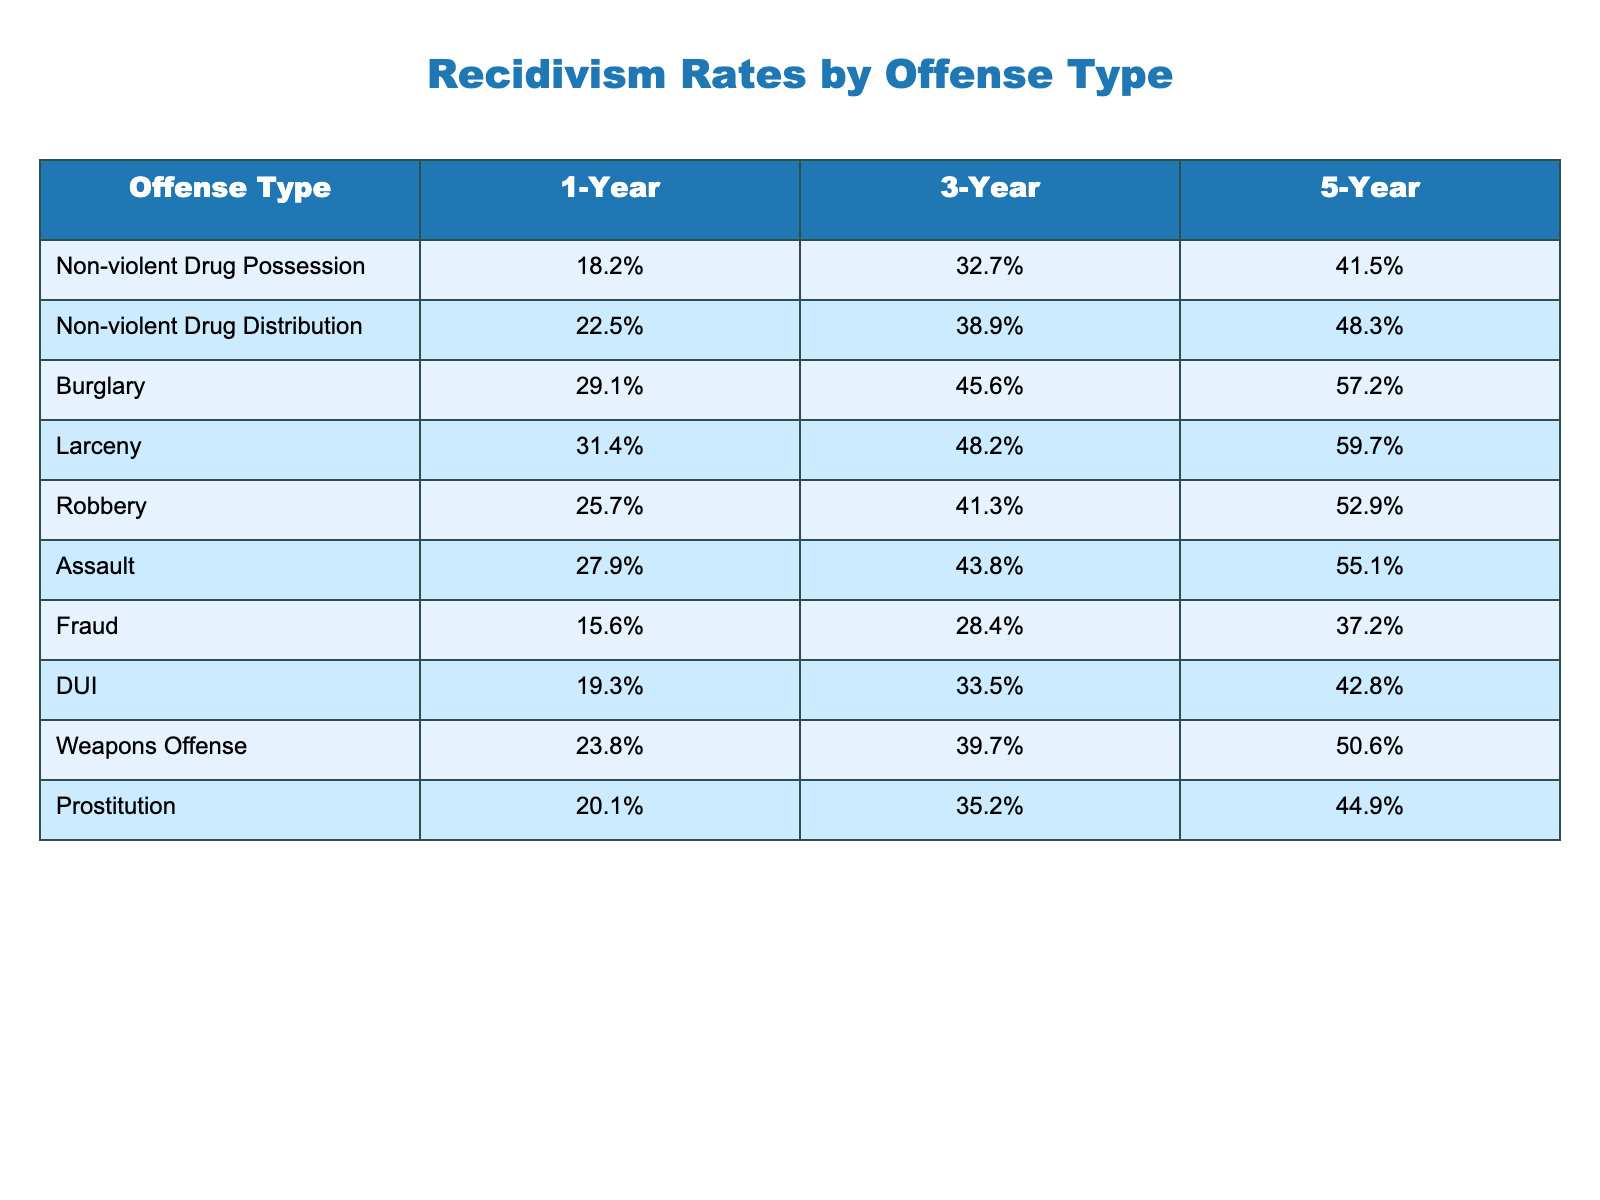What is the 1-year recidivism rate for non-violent drug possession? The table shows that the 1-Year Recidivism Rate for Non-violent Drug Possession is 18.2%.
Answer: 18.2% Which offense type has the highest 3-year recidivism rate? Looking at the 3-Year Recidivism Rates, Larceny has the highest rate at 48.2%.
Answer: Larceny What is the difference in the 5-year recidivism rates between non-violent drug distribution and burglary? The 5-Year Recidivism Rate for Non-violent Drug Distribution is 48.3% and for Burglary it is 57.2%. The difference is 57.2% - 48.3% = 8.9%.
Answer: 8.9% True or False: The 1-year recidivism rate for DUI is higher than that for fraud. The 1-Year Recidivism Rate for DUI is 19.3%, while for Fraud it is 15.6%. Since 19.3% is greater than 15.6%, the statement is True.
Answer: True What is the average 3-year recidivism rate for non-violent drug offenders (both possession and distribution)? The 3-Year Recidivism Rate for Non-violent Drug Possession is 32.7% and for Non-violent Drug Distribution is 38.9%. The average is (32.7% + 38.9%) / 2 = 35.8%.
Answer: 35.8% How much higher is the 5-year recidivism rate for assault compared to non-violent drug possession? The 5-Year Recidivism Rate for Assault is 55.1% and for Non-violent Drug Possession is 41.5%. The difference is 55.1% - 41.5% = 13.6%.
Answer: 13.6% Which two offense types have the closest 1-year recidivism rates? Comparing the 1-Year Recidivism Rates, Non-violent Drug Possession (18.2%) and DUI (19.3%) are the closest, differing by only 1.1%.
Answer: Non-violent Drug Possession and DUI What is the cumulative 5-year recidivism rate for non-violent drug offenders compared to robbery? For Non-violent Drug Possession, the 5-Year Rate is 41.5% and for Non-violent Drug Distribution, it is 48.3%, adding these gives 41.5% + 48.3% = 89.8%. The 5-Year Rate for Robbery is 52.9%. Therefore, Non-violent Drug Offenders' cumulative rate (89.8%) is higher than Robbery's rate (52.9%).
Answer: Higher True or False: The recidivism rates for burglary exceed 30% at the 1-year, 3-year, and 5-year marks. The 1-Year Recidivism Rate for Burglary is 29.1%, which is less than 30%. Therefore, the statement is False.
Answer: False What is the rate increase from the 1-year to the 5-year mark for non-violent drug distribution offenders? The 1-Year Recidivism Rate for Non-violent Drug Distribution is 22.5% and the 5-Year Rate is 48.3%. The increase is 48.3% - 22.5% = 25.8%.
Answer: 25.8% 